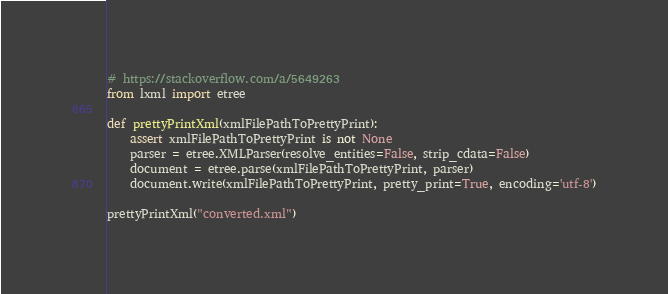<code> <loc_0><loc_0><loc_500><loc_500><_Python_># https://stackoverflow.com/a/5649263
from lxml import etree

def prettyPrintXml(xmlFilePathToPrettyPrint):
    assert xmlFilePathToPrettyPrint is not None
    parser = etree.XMLParser(resolve_entities=False, strip_cdata=False)
    document = etree.parse(xmlFilePathToPrettyPrint, parser)
    document.write(xmlFilePathToPrettyPrint, pretty_print=True, encoding='utf-8')

prettyPrintXml("converted.xml")</code> 